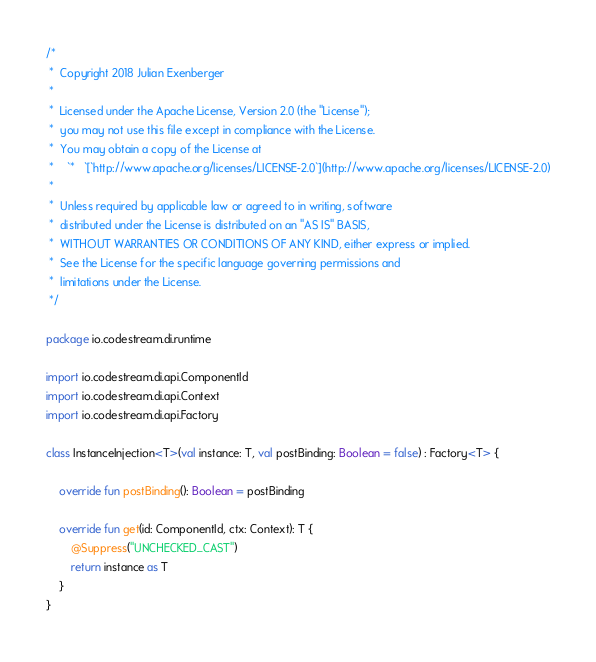<code> <loc_0><loc_0><loc_500><loc_500><_Kotlin_>/*
 *  Copyright 2018 Julian Exenberger
 *
 *  Licensed under the Apache License, Version 2.0 (the "License");
 *  you may not use this file except in compliance with the License.
 *  You may obtain a copy of the License at
 *    `*   `[`http://www.apache.org/licenses/LICENSE-2.0`](http://www.apache.org/licenses/LICENSE-2.0)
 *
 *  Unless required by applicable law or agreed to in writing, software
 *  distributed under the License is distributed on an "AS IS" BASIS,
 *  WITHOUT WARRANTIES OR CONDITIONS OF ANY KIND, either express or implied.
 *  See the License for the specific language governing permissions and
 *  limitations under the License.
 */

package io.codestream.di.runtime

import io.codestream.di.api.ComponentId
import io.codestream.di.api.Context
import io.codestream.di.api.Factory

class InstanceInjection<T>(val instance: T, val postBinding: Boolean = false) : Factory<T> {

    override fun postBinding(): Boolean = postBinding

    override fun get(id: ComponentId, ctx: Context): T {
        @Suppress("UNCHECKED_CAST")
        return instance as T
    }
}</code> 